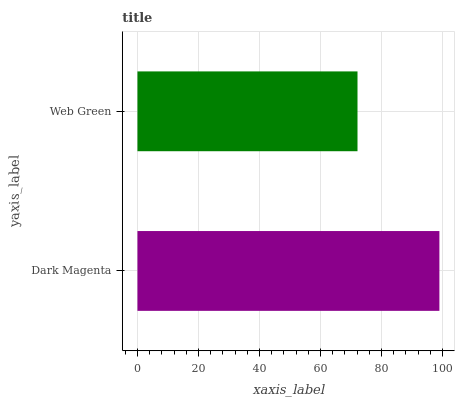Is Web Green the minimum?
Answer yes or no. Yes. Is Dark Magenta the maximum?
Answer yes or no. Yes. Is Web Green the maximum?
Answer yes or no. No. Is Dark Magenta greater than Web Green?
Answer yes or no. Yes. Is Web Green less than Dark Magenta?
Answer yes or no. Yes. Is Web Green greater than Dark Magenta?
Answer yes or no. No. Is Dark Magenta less than Web Green?
Answer yes or no. No. Is Dark Magenta the high median?
Answer yes or no. Yes. Is Web Green the low median?
Answer yes or no. Yes. Is Web Green the high median?
Answer yes or no. No. Is Dark Magenta the low median?
Answer yes or no. No. 